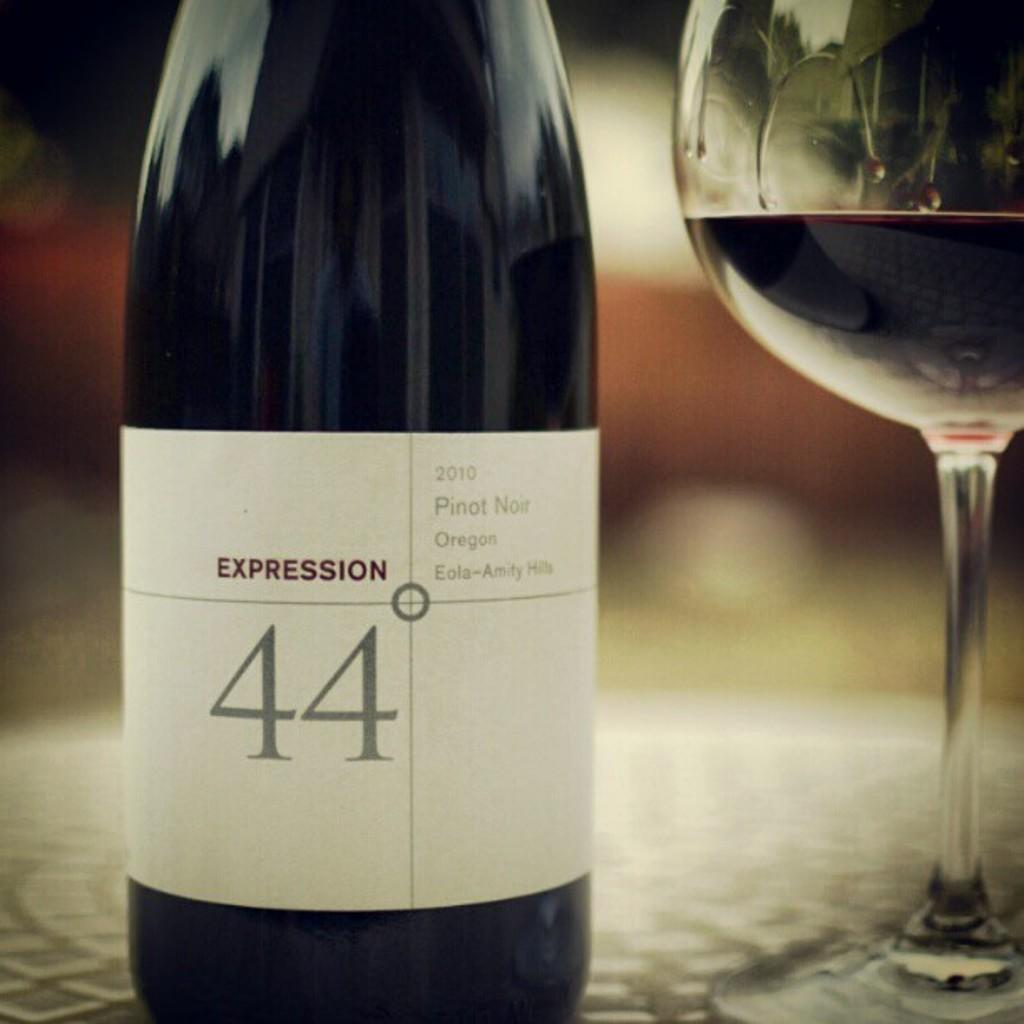<image>
Share a concise interpretation of the image provided. A bottle of Expression 44 pinot noir from 2010. 